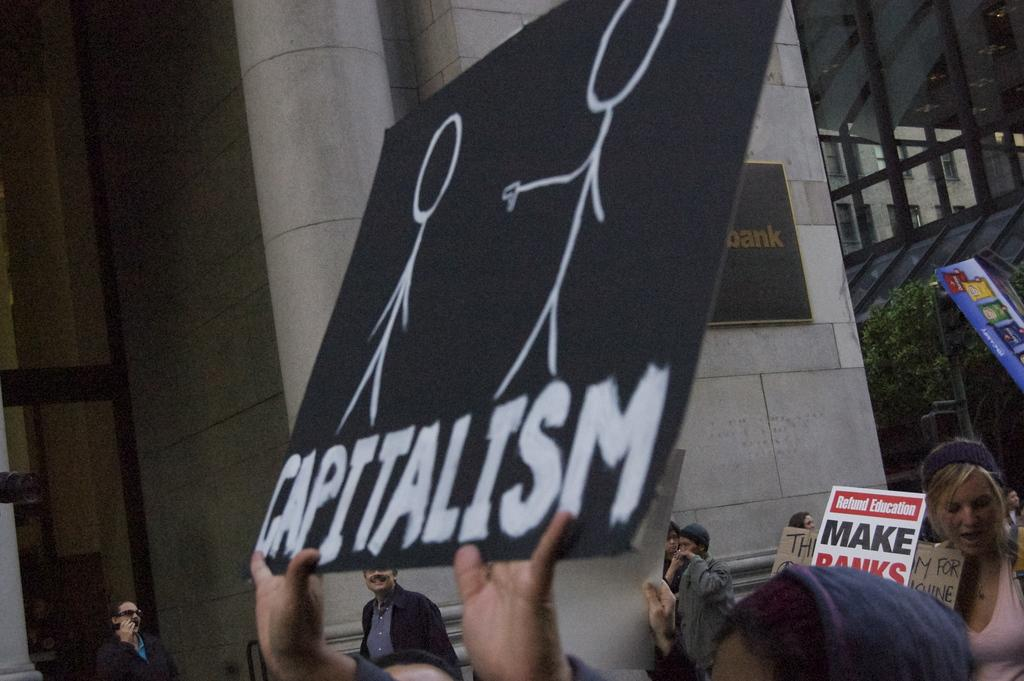What is the person holding in the image? The person is holding a black color poster in the image. Can you describe the people in the image? There are people standing in the image. What type of vegetation is on the right side of the image? There is a tree on the right side of the image. What structure is visible in the image? There is a wall visible in the image. What type of meat is being served to the people in the image? There is no meat present in the image; it only shows a person holding a black color poster and people standing nearby. 